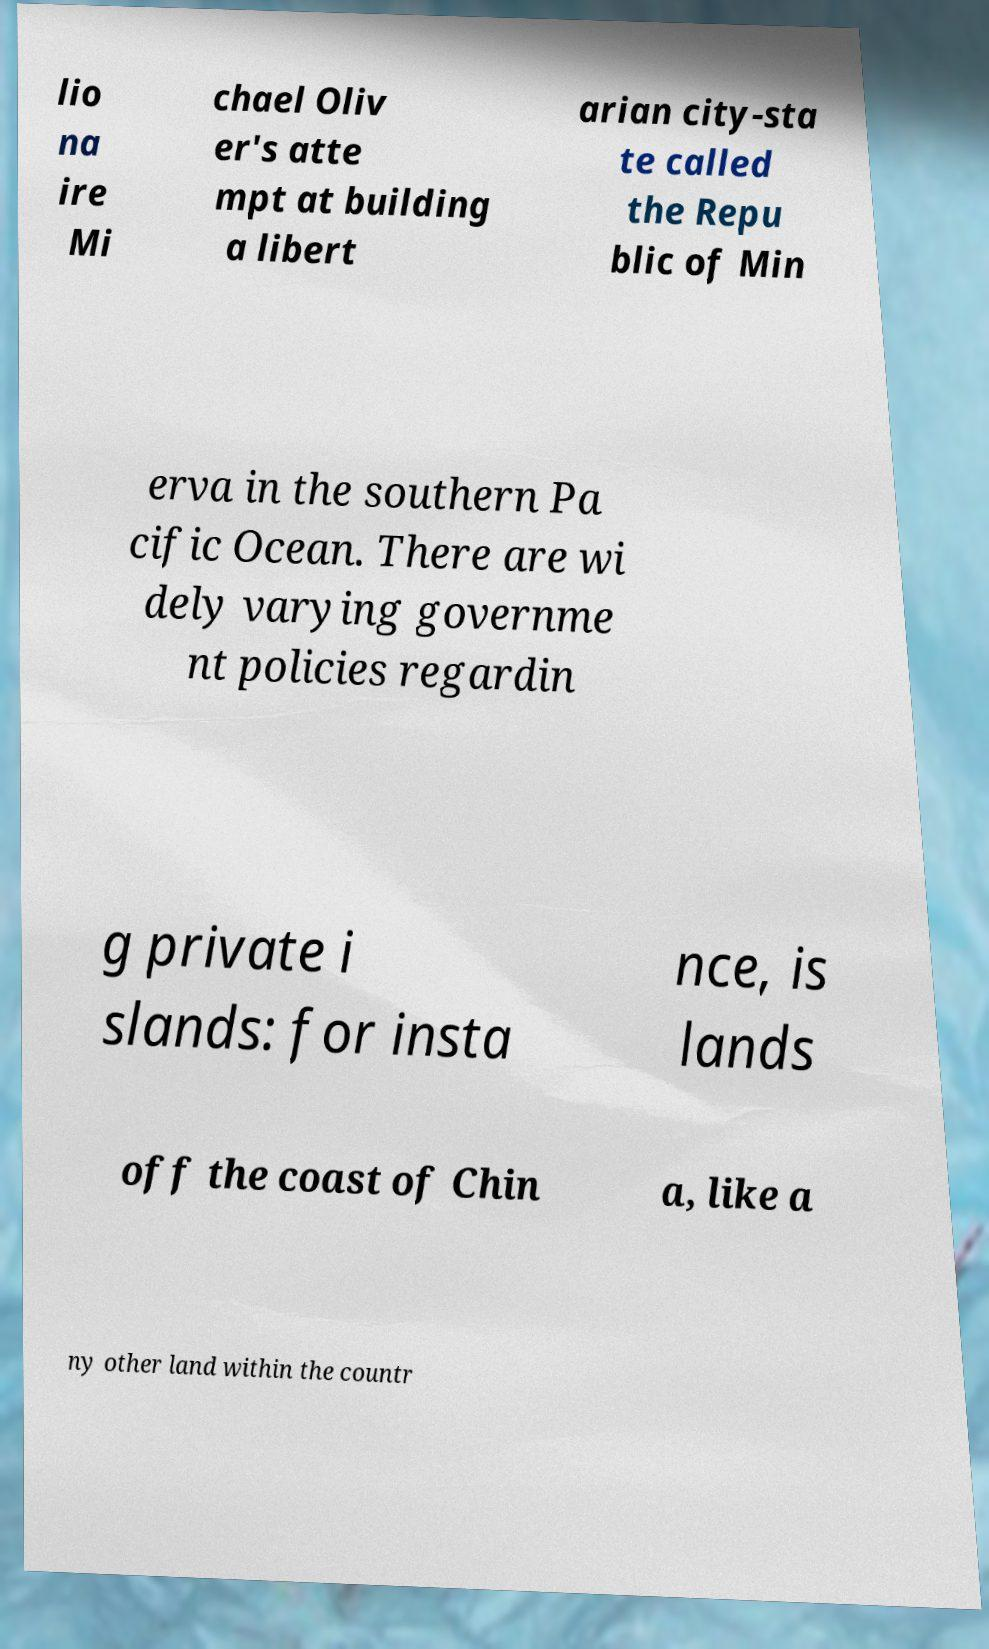Could you assist in decoding the text presented in this image and type it out clearly? lio na ire Mi chael Oliv er's atte mpt at building a libert arian city-sta te called the Repu blic of Min erva in the southern Pa cific Ocean. There are wi dely varying governme nt policies regardin g private i slands: for insta nce, is lands off the coast of Chin a, like a ny other land within the countr 